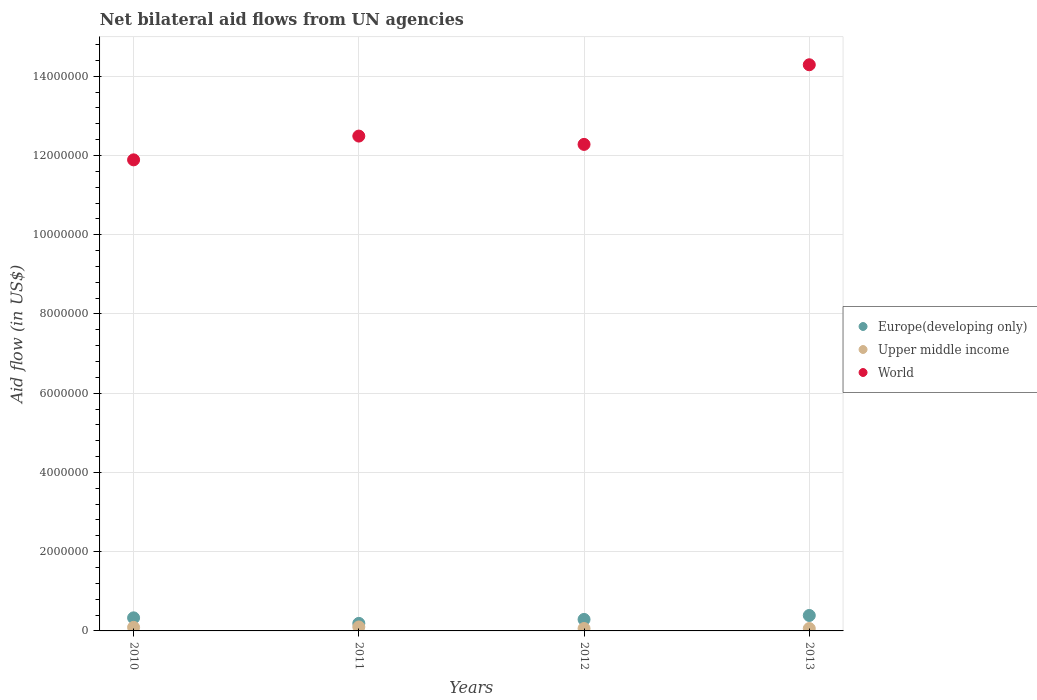How many different coloured dotlines are there?
Keep it short and to the point. 3. Is the number of dotlines equal to the number of legend labels?
Your answer should be very brief. Yes. What is the net bilateral aid flow in Upper middle income in 2013?
Your answer should be very brief. 6.00e+04. Across all years, what is the maximum net bilateral aid flow in Upper middle income?
Keep it short and to the point. 1.00e+05. Across all years, what is the minimum net bilateral aid flow in Upper middle income?
Your response must be concise. 6.00e+04. In which year was the net bilateral aid flow in Upper middle income minimum?
Provide a short and direct response. 2012. What is the total net bilateral aid flow in World in the graph?
Your answer should be compact. 5.10e+07. What is the difference between the net bilateral aid flow in Upper middle income in 2010 and the net bilateral aid flow in World in 2012?
Offer a very short reply. -1.22e+07. What is the average net bilateral aid flow in Europe(developing only) per year?
Make the answer very short. 3.00e+05. In the year 2010, what is the difference between the net bilateral aid flow in Upper middle income and net bilateral aid flow in Europe(developing only)?
Keep it short and to the point. -2.40e+05. What is the ratio of the net bilateral aid flow in World in 2012 to that in 2013?
Give a very brief answer. 0.86. Is the net bilateral aid flow in World in 2011 less than that in 2012?
Offer a terse response. No. Is the difference between the net bilateral aid flow in Upper middle income in 2011 and 2013 greater than the difference between the net bilateral aid flow in Europe(developing only) in 2011 and 2013?
Keep it short and to the point. Yes. What is the difference between the highest and the second highest net bilateral aid flow in World?
Provide a succinct answer. 1.80e+06. What is the difference between the highest and the lowest net bilateral aid flow in Upper middle income?
Ensure brevity in your answer.  4.00e+04. Is it the case that in every year, the sum of the net bilateral aid flow in Upper middle income and net bilateral aid flow in Europe(developing only)  is greater than the net bilateral aid flow in World?
Your response must be concise. No. Is the net bilateral aid flow in Europe(developing only) strictly greater than the net bilateral aid flow in World over the years?
Offer a very short reply. No. Is the net bilateral aid flow in Upper middle income strictly less than the net bilateral aid flow in Europe(developing only) over the years?
Ensure brevity in your answer.  Yes. Does the graph contain any zero values?
Make the answer very short. No. Where does the legend appear in the graph?
Your answer should be compact. Center right. How are the legend labels stacked?
Keep it short and to the point. Vertical. What is the title of the graph?
Offer a terse response. Net bilateral aid flows from UN agencies. Does "Kuwait" appear as one of the legend labels in the graph?
Give a very brief answer. No. What is the label or title of the Y-axis?
Ensure brevity in your answer.  Aid flow (in US$). What is the Aid flow (in US$) in Europe(developing only) in 2010?
Offer a terse response. 3.30e+05. What is the Aid flow (in US$) of World in 2010?
Make the answer very short. 1.19e+07. What is the Aid flow (in US$) in Europe(developing only) in 2011?
Ensure brevity in your answer.  1.90e+05. What is the Aid flow (in US$) in World in 2011?
Provide a short and direct response. 1.25e+07. What is the Aid flow (in US$) of Europe(developing only) in 2012?
Ensure brevity in your answer.  2.90e+05. What is the Aid flow (in US$) of Upper middle income in 2012?
Ensure brevity in your answer.  6.00e+04. What is the Aid flow (in US$) of World in 2012?
Your answer should be compact. 1.23e+07. What is the Aid flow (in US$) of Upper middle income in 2013?
Your answer should be very brief. 6.00e+04. What is the Aid flow (in US$) of World in 2013?
Your answer should be very brief. 1.43e+07. Across all years, what is the maximum Aid flow (in US$) in Europe(developing only)?
Give a very brief answer. 3.90e+05. Across all years, what is the maximum Aid flow (in US$) of World?
Offer a very short reply. 1.43e+07. Across all years, what is the minimum Aid flow (in US$) in Upper middle income?
Your answer should be very brief. 6.00e+04. Across all years, what is the minimum Aid flow (in US$) in World?
Ensure brevity in your answer.  1.19e+07. What is the total Aid flow (in US$) in Europe(developing only) in the graph?
Give a very brief answer. 1.20e+06. What is the total Aid flow (in US$) in Upper middle income in the graph?
Ensure brevity in your answer.  3.10e+05. What is the total Aid flow (in US$) in World in the graph?
Provide a short and direct response. 5.10e+07. What is the difference between the Aid flow (in US$) in Upper middle income in 2010 and that in 2011?
Give a very brief answer. -10000. What is the difference between the Aid flow (in US$) in World in 2010 and that in 2011?
Provide a succinct answer. -6.00e+05. What is the difference between the Aid flow (in US$) of Europe(developing only) in 2010 and that in 2012?
Your answer should be very brief. 4.00e+04. What is the difference between the Aid flow (in US$) in World in 2010 and that in 2012?
Offer a terse response. -3.90e+05. What is the difference between the Aid flow (in US$) of Europe(developing only) in 2010 and that in 2013?
Provide a succinct answer. -6.00e+04. What is the difference between the Aid flow (in US$) of World in 2010 and that in 2013?
Keep it short and to the point. -2.40e+06. What is the difference between the Aid flow (in US$) of World in 2011 and that in 2013?
Your answer should be very brief. -1.80e+06. What is the difference between the Aid flow (in US$) in Europe(developing only) in 2012 and that in 2013?
Make the answer very short. -1.00e+05. What is the difference between the Aid flow (in US$) in Upper middle income in 2012 and that in 2013?
Provide a short and direct response. 0. What is the difference between the Aid flow (in US$) in World in 2012 and that in 2013?
Ensure brevity in your answer.  -2.01e+06. What is the difference between the Aid flow (in US$) of Europe(developing only) in 2010 and the Aid flow (in US$) of World in 2011?
Your answer should be very brief. -1.22e+07. What is the difference between the Aid flow (in US$) of Upper middle income in 2010 and the Aid flow (in US$) of World in 2011?
Give a very brief answer. -1.24e+07. What is the difference between the Aid flow (in US$) of Europe(developing only) in 2010 and the Aid flow (in US$) of Upper middle income in 2012?
Keep it short and to the point. 2.70e+05. What is the difference between the Aid flow (in US$) in Europe(developing only) in 2010 and the Aid flow (in US$) in World in 2012?
Keep it short and to the point. -1.20e+07. What is the difference between the Aid flow (in US$) of Upper middle income in 2010 and the Aid flow (in US$) of World in 2012?
Offer a very short reply. -1.22e+07. What is the difference between the Aid flow (in US$) of Europe(developing only) in 2010 and the Aid flow (in US$) of Upper middle income in 2013?
Provide a succinct answer. 2.70e+05. What is the difference between the Aid flow (in US$) in Europe(developing only) in 2010 and the Aid flow (in US$) in World in 2013?
Provide a short and direct response. -1.40e+07. What is the difference between the Aid flow (in US$) in Upper middle income in 2010 and the Aid flow (in US$) in World in 2013?
Your response must be concise. -1.42e+07. What is the difference between the Aid flow (in US$) in Europe(developing only) in 2011 and the Aid flow (in US$) in Upper middle income in 2012?
Offer a terse response. 1.30e+05. What is the difference between the Aid flow (in US$) in Europe(developing only) in 2011 and the Aid flow (in US$) in World in 2012?
Your answer should be compact. -1.21e+07. What is the difference between the Aid flow (in US$) of Upper middle income in 2011 and the Aid flow (in US$) of World in 2012?
Keep it short and to the point. -1.22e+07. What is the difference between the Aid flow (in US$) of Europe(developing only) in 2011 and the Aid flow (in US$) of World in 2013?
Give a very brief answer. -1.41e+07. What is the difference between the Aid flow (in US$) in Upper middle income in 2011 and the Aid flow (in US$) in World in 2013?
Give a very brief answer. -1.42e+07. What is the difference between the Aid flow (in US$) in Europe(developing only) in 2012 and the Aid flow (in US$) in World in 2013?
Make the answer very short. -1.40e+07. What is the difference between the Aid flow (in US$) of Upper middle income in 2012 and the Aid flow (in US$) of World in 2013?
Your answer should be compact. -1.42e+07. What is the average Aid flow (in US$) of Upper middle income per year?
Offer a terse response. 7.75e+04. What is the average Aid flow (in US$) of World per year?
Keep it short and to the point. 1.27e+07. In the year 2010, what is the difference between the Aid flow (in US$) of Europe(developing only) and Aid flow (in US$) of Upper middle income?
Offer a terse response. 2.40e+05. In the year 2010, what is the difference between the Aid flow (in US$) of Europe(developing only) and Aid flow (in US$) of World?
Provide a short and direct response. -1.16e+07. In the year 2010, what is the difference between the Aid flow (in US$) of Upper middle income and Aid flow (in US$) of World?
Keep it short and to the point. -1.18e+07. In the year 2011, what is the difference between the Aid flow (in US$) in Europe(developing only) and Aid flow (in US$) in Upper middle income?
Your answer should be very brief. 9.00e+04. In the year 2011, what is the difference between the Aid flow (in US$) in Europe(developing only) and Aid flow (in US$) in World?
Offer a very short reply. -1.23e+07. In the year 2011, what is the difference between the Aid flow (in US$) of Upper middle income and Aid flow (in US$) of World?
Offer a terse response. -1.24e+07. In the year 2012, what is the difference between the Aid flow (in US$) of Europe(developing only) and Aid flow (in US$) of World?
Offer a very short reply. -1.20e+07. In the year 2012, what is the difference between the Aid flow (in US$) of Upper middle income and Aid flow (in US$) of World?
Ensure brevity in your answer.  -1.22e+07. In the year 2013, what is the difference between the Aid flow (in US$) of Europe(developing only) and Aid flow (in US$) of World?
Your answer should be very brief. -1.39e+07. In the year 2013, what is the difference between the Aid flow (in US$) in Upper middle income and Aid flow (in US$) in World?
Your response must be concise. -1.42e+07. What is the ratio of the Aid flow (in US$) of Europe(developing only) in 2010 to that in 2011?
Your response must be concise. 1.74. What is the ratio of the Aid flow (in US$) of Upper middle income in 2010 to that in 2011?
Your answer should be compact. 0.9. What is the ratio of the Aid flow (in US$) in World in 2010 to that in 2011?
Provide a short and direct response. 0.95. What is the ratio of the Aid flow (in US$) in Europe(developing only) in 2010 to that in 2012?
Give a very brief answer. 1.14. What is the ratio of the Aid flow (in US$) in Upper middle income in 2010 to that in 2012?
Offer a terse response. 1.5. What is the ratio of the Aid flow (in US$) of World in 2010 to that in 2012?
Your answer should be very brief. 0.97. What is the ratio of the Aid flow (in US$) of Europe(developing only) in 2010 to that in 2013?
Provide a succinct answer. 0.85. What is the ratio of the Aid flow (in US$) of Upper middle income in 2010 to that in 2013?
Offer a terse response. 1.5. What is the ratio of the Aid flow (in US$) of World in 2010 to that in 2013?
Provide a short and direct response. 0.83. What is the ratio of the Aid flow (in US$) in Europe(developing only) in 2011 to that in 2012?
Provide a short and direct response. 0.66. What is the ratio of the Aid flow (in US$) in Upper middle income in 2011 to that in 2012?
Offer a terse response. 1.67. What is the ratio of the Aid flow (in US$) in World in 2011 to that in 2012?
Your answer should be compact. 1.02. What is the ratio of the Aid flow (in US$) in Europe(developing only) in 2011 to that in 2013?
Ensure brevity in your answer.  0.49. What is the ratio of the Aid flow (in US$) in World in 2011 to that in 2013?
Make the answer very short. 0.87. What is the ratio of the Aid flow (in US$) of Europe(developing only) in 2012 to that in 2013?
Give a very brief answer. 0.74. What is the ratio of the Aid flow (in US$) in World in 2012 to that in 2013?
Ensure brevity in your answer.  0.86. What is the difference between the highest and the second highest Aid flow (in US$) in World?
Your answer should be very brief. 1.80e+06. What is the difference between the highest and the lowest Aid flow (in US$) of Europe(developing only)?
Ensure brevity in your answer.  2.00e+05. What is the difference between the highest and the lowest Aid flow (in US$) in Upper middle income?
Keep it short and to the point. 4.00e+04. What is the difference between the highest and the lowest Aid flow (in US$) in World?
Ensure brevity in your answer.  2.40e+06. 